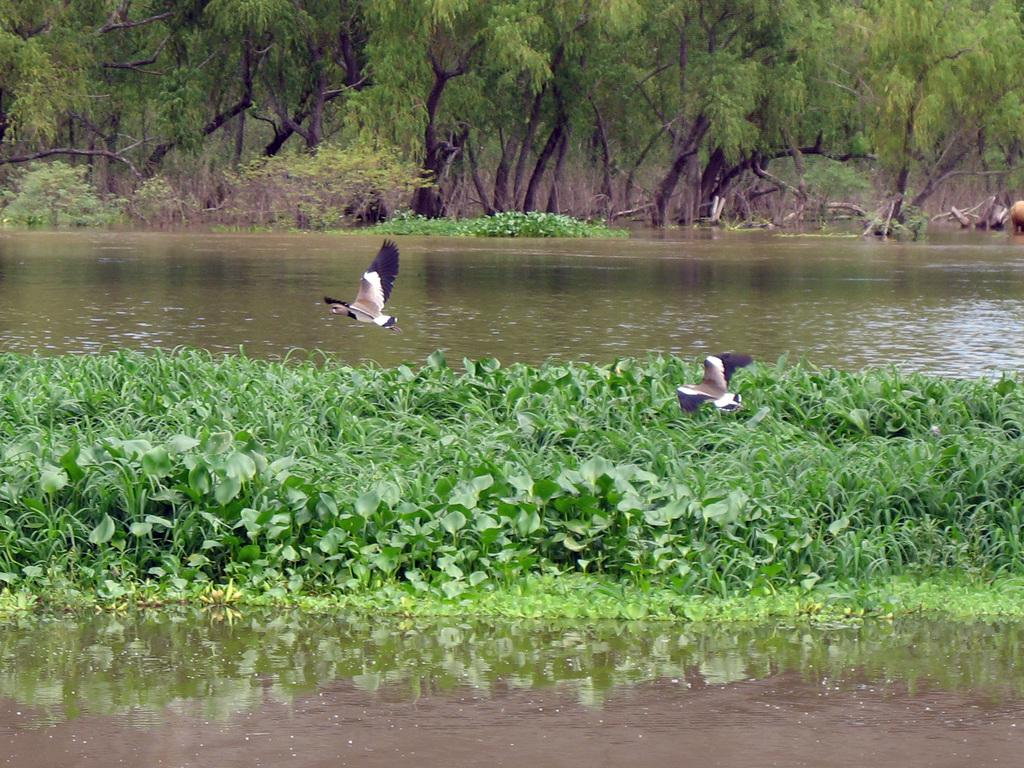What is located in the center of the image? There are birds and water in the center of the image. What can be seen at the bottom of the image? The ground is visible at the bottom of the image, along with plants. What is visible in the background of the image? Trees and plants are visible in the background of the image. What type of toy can be seen in the image? There is no toy present in the image. What is the desire of the birds in the image? The image does not provide information about the desires of the birds. 